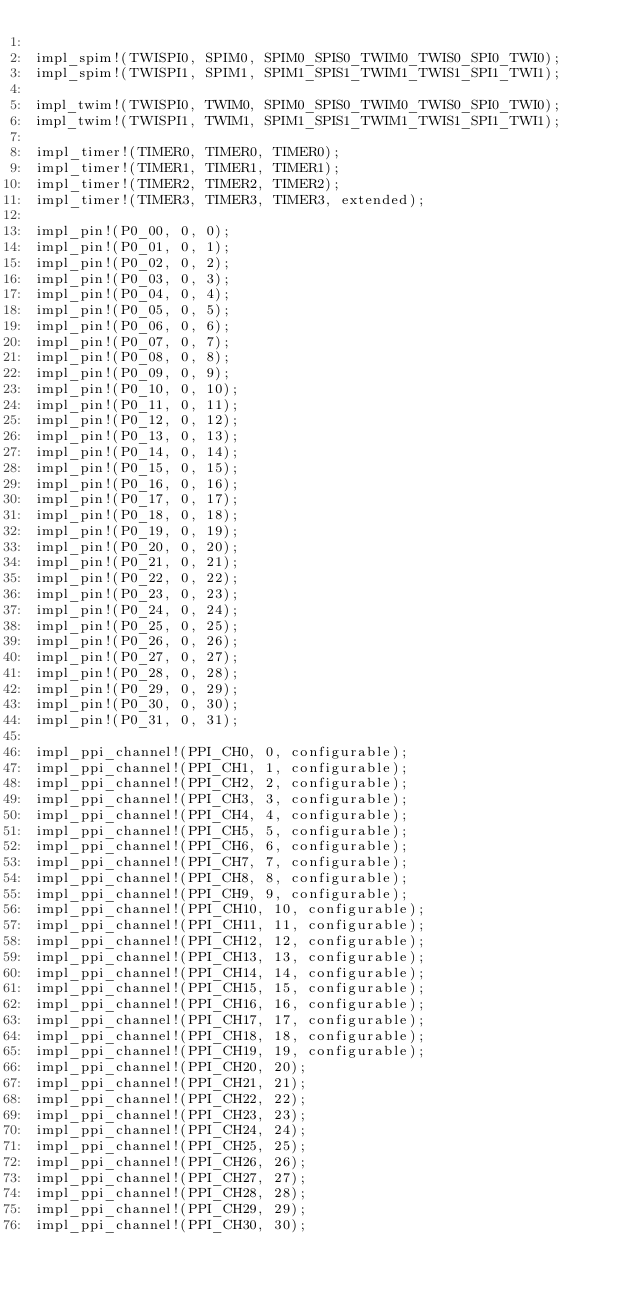Convert code to text. <code><loc_0><loc_0><loc_500><loc_500><_Rust_>
impl_spim!(TWISPI0, SPIM0, SPIM0_SPIS0_TWIM0_TWIS0_SPI0_TWI0);
impl_spim!(TWISPI1, SPIM1, SPIM1_SPIS1_TWIM1_TWIS1_SPI1_TWI1);

impl_twim!(TWISPI0, TWIM0, SPIM0_SPIS0_TWIM0_TWIS0_SPI0_TWI0);
impl_twim!(TWISPI1, TWIM1, SPIM1_SPIS1_TWIM1_TWIS1_SPI1_TWI1);

impl_timer!(TIMER0, TIMER0, TIMER0);
impl_timer!(TIMER1, TIMER1, TIMER1);
impl_timer!(TIMER2, TIMER2, TIMER2);
impl_timer!(TIMER3, TIMER3, TIMER3, extended);

impl_pin!(P0_00, 0, 0);
impl_pin!(P0_01, 0, 1);
impl_pin!(P0_02, 0, 2);
impl_pin!(P0_03, 0, 3);
impl_pin!(P0_04, 0, 4);
impl_pin!(P0_05, 0, 5);
impl_pin!(P0_06, 0, 6);
impl_pin!(P0_07, 0, 7);
impl_pin!(P0_08, 0, 8);
impl_pin!(P0_09, 0, 9);
impl_pin!(P0_10, 0, 10);
impl_pin!(P0_11, 0, 11);
impl_pin!(P0_12, 0, 12);
impl_pin!(P0_13, 0, 13);
impl_pin!(P0_14, 0, 14);
impl_pin!(P0_15, 0, 15);
impl_pin!(P0_16, 0, 16);
impl_pin!(P0_17, 0, 17);
impl_pin!(P0_18, 0, 18);
impl_pin!(P0_19, 0, 19);
impl_pin!(P0_20, 0, 20);
impl_pin!(P0_21, 0, 21);
impl_pin!(P0_22, 0, 22);
impl_pin!(P0_23, 0, 23);
impl_pin!(P0_24, 0, 24);
impl_pin!(P0_25, 0, 25);
impl_pin!(P0_26, 0, 26);
impl_pin!(P0_27, 0, 27);
impl_pin!(P0_28, 0, 28);
impl_pin!(P0_29, 0, 29);
impl_pin!(P0_30, 0, 30);
impl_pin!(P0_31, 0, 31);

impl_ppi_channel!(PPI_CH0, 0, configurable);
impl_ppi_channel!(PPI_CH1, 1, configurable);
impl_ppi_channel!(PPI_CH2, 2, configurable);
impl_ppi_channel!(PPI_CH3, 3, configurable);
impl_ppi_channel!(PPI_CH4, 4, configurable);
impl_ppi_channel!(PPI_CH5, 5, configurable);
impl_ppi_channel!(PPI_CH6, 6, configurable);
impl_ppi_channel!(PPI_CH7, 7, configurable);
impl_ppi_channel!(PPI_CH8, 8, configurable);
impl_ppi_channel!(PPI_CH9, 9, configurable);
impl_ppi_channel!(PPI_CH10, 10, configurable);
impl_ppi_channel!(PPI_CH11, 11, configurable);
impl_ppi_channel!(PPI_CH12, 12, configurable);
impl_ppi_channel!(PPI_CH13, 13, configurable);
impl_ppi_channel!(PPI_CH14, 14, configurable);
impl_ppi_channel!(PPI_CH15, 15, configurable);
impl_ppi_channel!(PPI_CH16, 16, configurable);
impl_ppi_channel!(PPI_CH17, 17, configurable);
impl_ppi_channel!(PPI_CH18, 18, configurable);
impl_ppi_channel!(PPI_CH19, 19, configurable);
impl_ppi_channel!(PPI_CH20, 20);
impl_ppi_channel!(PPI_CH21, 21);
impl_ppi_channel!(PPI_CH22, 22);
impl_ppi_channel!(PPI_CH23, 23);
impl_ppi_channel!(PPI_CH24, 24);
impl_ppi_channel!(PPI_CH25, 25);
impl_ppi_channel!(PPI_CH26, 26);
impl_ppi_channel!(PPI_CH27, 27);
impl_ppi_channel!(PPI_CH28, 28);
impl_ppi_channel!(PPI_CH29, 29);
impl_ppi_channel!(PPI_CH30, 30);</code> 